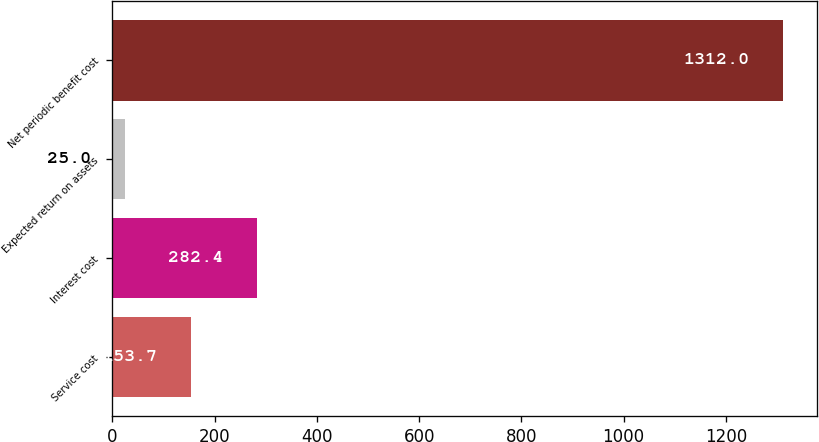<chart> <loc_0><loc_0><loc_500><loc_500><bar_chart><fcel>Service cost<fcel>Interest cost<fcel>Expected return on assets<fcel>Net periodic benefit cost<nl><fcel>153.7<fcel>282.4<fcel>25<fcel>1312<nl></chart> 